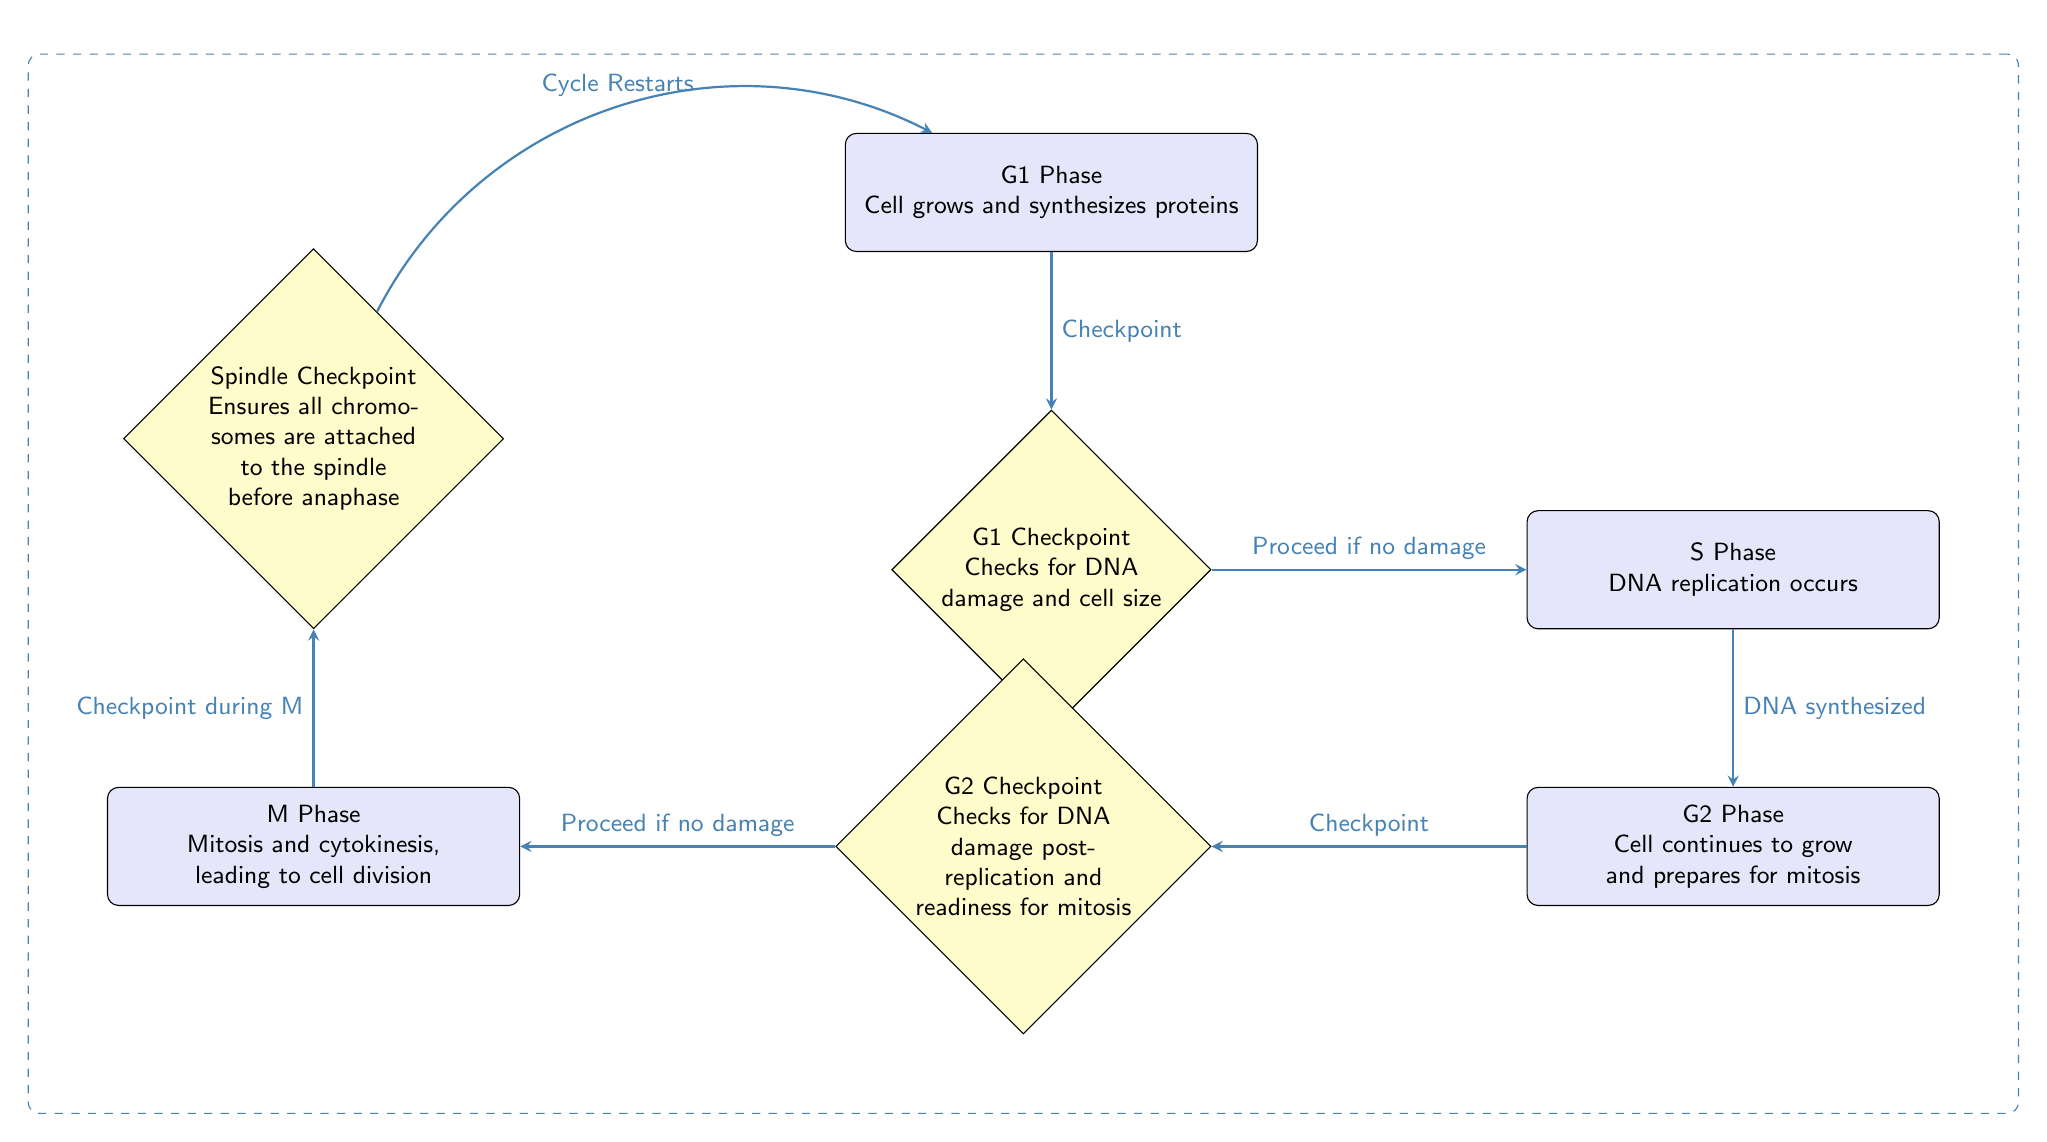What are the stages in the cell cycle represented in the diagram? The diagram shows four stages in the cell cycle: G1 Phase, S Phase, G2 Phase, and M Phase, arranged sequentially.
Answer: G1 Phase, S Phase, G2 Phase, M Phase What does the G1 Checkpoint check for? The diagram specifies that the G1 Checkpoint checks for DNA damage and verifies cell size before proceeding to the S phase.
Answer: DNA damage and cell size Which phase follows the S Phase? Referring to the flowchart, the S Phase leads directly into the G2 Phase, indicating that this is the next stage after S.
Answer: G2 Phase What is the purpose of the Spindle Checkpoint? The diagram indicates that the Spindle Checkpoint ensures that all chromosomes are attached to the spindle before the cell proceeds to anaphase during mitosis.
Answer: Ensures all chromosomes are attached How many checkpoints are illustrated in the diagram? By reviewing the diagram, there are three checkpoints labeled: G1 Checkpoint, G2 Checkpoint, and Spindle Checkpoint, resulting in a total count of checkpoints specified.
Answer: 3 What happens during the G2 Phase? The diagram describes that during the G2 Phase, the cell continues to grow and prepares for mitosis, indicating important activities in this phase.
Answer: Cell continues to grow and prepares for mitosis What must occur after the G2 Checkpoint if no damage is found? The diagram states that if no damage is found at the G2 Checkpoint, the cell proceeds to the M Phase, demonstrating the flow from G2 to M in the cycle.
Answer: Proceed to M Phase Describe the transition from the M Phase in the diagram. The flow from the M Phase indicates that there is a checkpoint during M, leading into the Spindle Checkpoint, which ultimately redirects back to G1 if all conditions are satisfied.
Answer: Leads to Spindle Checkpoint, Cycle Restarts What event specifically occurs in the S Phase of the cell cycle? The diagram clearly identifies that the specific event occurring in the S Phase is DNA replication, marking an essential process of this cell cycle stage.
Answer: DNA replication occurs 